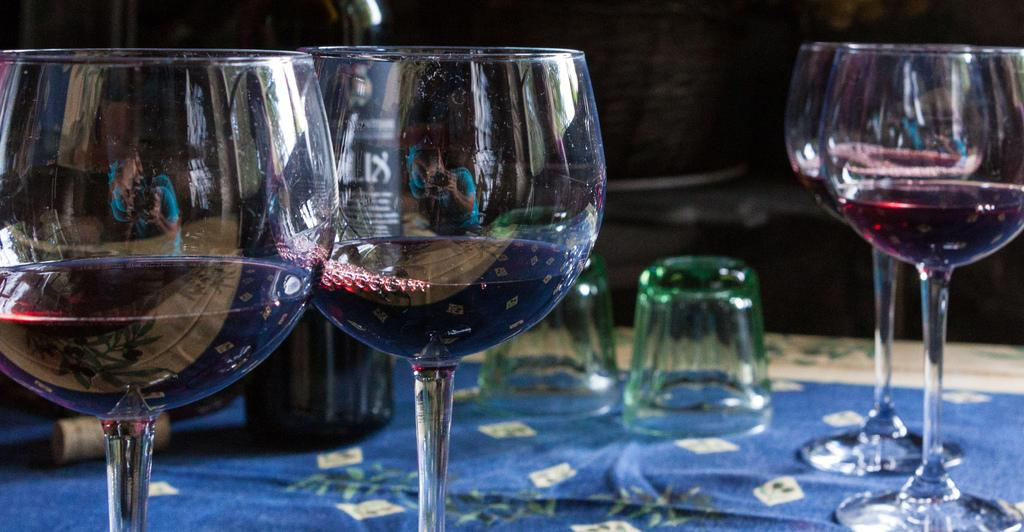What objects are present in the image that are typically used for drinking? There are glasses in the image, and some of them contain liquid. What other object related to drinking can be seen in the image? There is a bottle in the image. Is there any object in the image that is used to seal the bottle? Yes, there is a cap in the image. Where are the glasses, bottle, and cap located in the image? They are all on a table. What type of star can be seen shining brightly in the image? There is no star visible in the image; it features glasses, a bottle, a cap, and a table. 